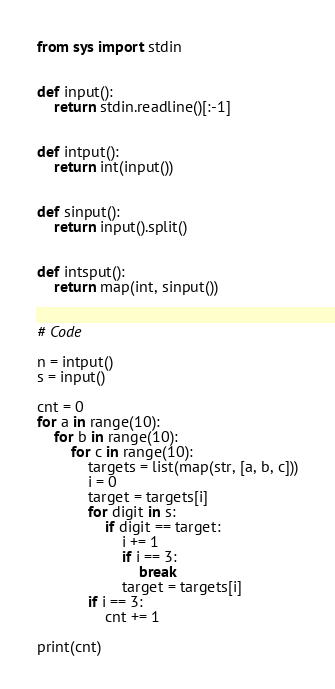Convert code to text. <code><loc_0><loc_0><loc_500><loc_500><_Python_>from sys import stdin


def input():
    return stdin.readline()[:-1]


def intput():
    return int(input())


def sinput():
    return input().split()


def intsput():
    return map(int, sinput())


# Code

n = intput()
s = input()

cnt = 0
for a in range(10):
    for b in range(10):
        for c in range(10):
            targets = list(map(str, [a, b, c]))
            i = 0
            target = targets[i]
            for digit in s:
                if digit == target:
                    i += 1
                    if i == 3:
                        break
                    target = targets[i]
            if i == 3:
                cnt += 1

print(cnt)
</code> 